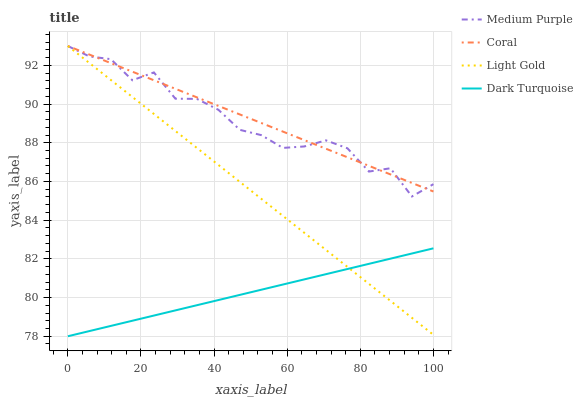Does Dark Turquoise have the minimum area under the curve?
Answer yes or no. Yes. Does Coral have the maximum area under the curve?
Answer yes or no. Yes. Does Coral have the minimum area under the curve?
Answer yes or no. No. Does Dark Turquoise have the maximum area under the curve?
Answer yes or no. No. Is Dark Turquoise the smoothest?
Answer yes or no. Yes. Is Medium Purple the roughest?
Answer yes or no. Yes. Is Coral the smoothest?
Answer yes or no. No. Is Coral the roughest?
Answer yes or no. No. Does Dark Turquoise have the lowest value?
Answer yes or no. Yes. Does Coral have the lowest value?
Answer yes or no. No. Does Light Gold have the highest value?
Answer yes or no. Yes. Does Dark Turquoise have the highest value?
Answer yes or no. No. Is Dark Turquoise less than Medium Purple?
Answer yes or no. Yes. Is Coral greater than Dark Turquoise?
Answer yes or no. Yes. Does Dark Turquoise intersect Light Gold?
Answer yes or no. Yes. Is Dark Turquoise less than Light Gold?
Answer yes or no. No. Is Dark Turquoise greater than Light Gold?
Answer yes or no. No. Does Dark Turquoise intersect Medium Purple?
Answer yes or no. No. 